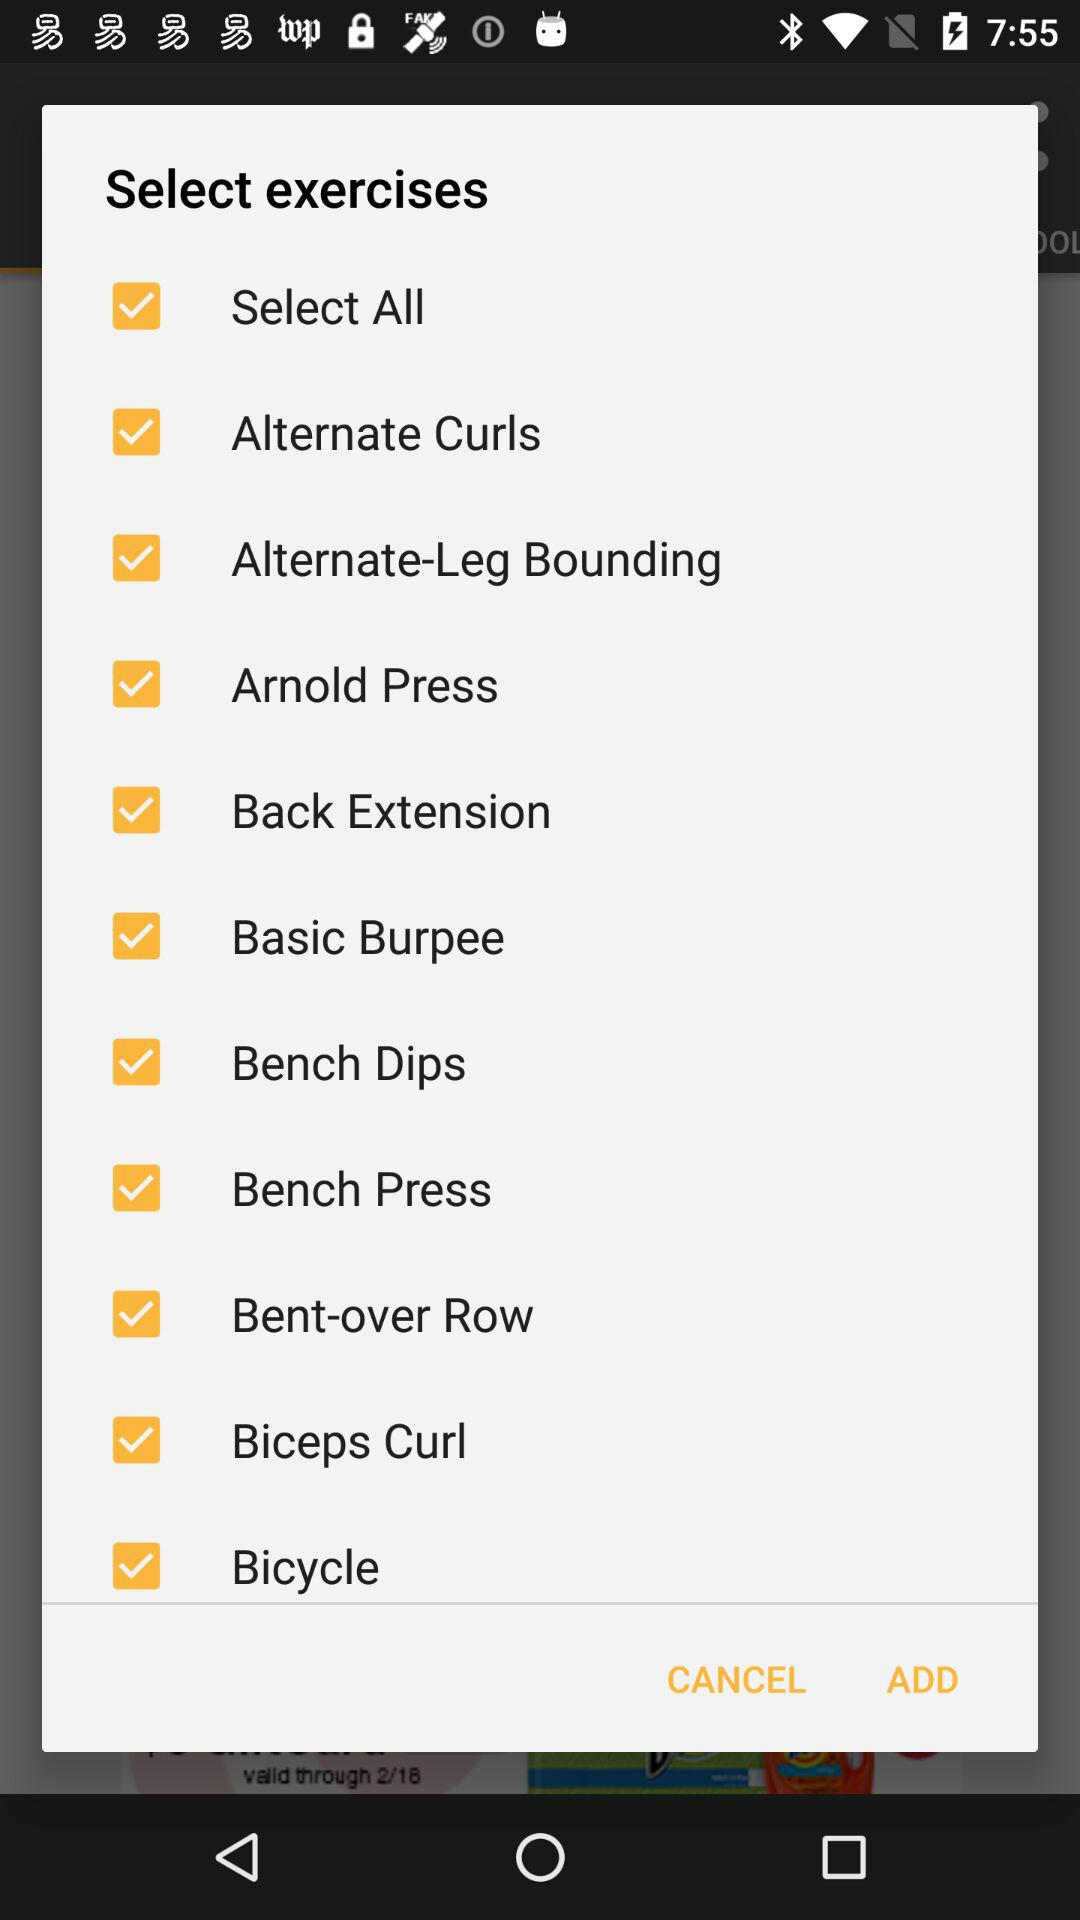Are any triceps workouts selected?
When the provided information is insufficient, respond with <no answer>. <no answer> 